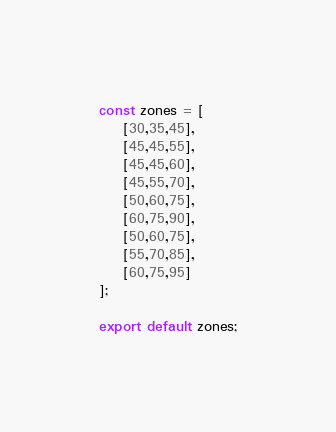Convert code to text. <code><loc_0><loc_0><loc_500><loc_500><_JavaScript_>const zones = [
	[30,35,45],
	[45,45,55],
	[45,45,60],
	[45,55,70],
	[50,60,75],
	[60,75,90],
	[50,60,75],
	[55,70,85],
	[60,75,95]
];

export default zones;</code> 